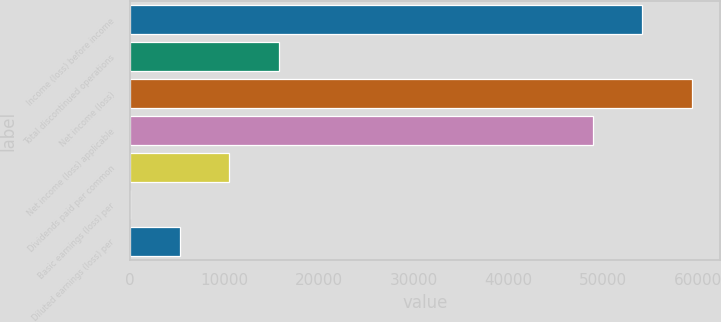<chart> <loc_0><loc_0><loc_500><loc_500><bar_chart><fcel>Income (loss) before income<fcel>Total discontinued operations<fcel>Net income (loss)<fcel>Net income (loss) applicable<fcel>Dividends paid per common<fcel>Basic earnings (loss) per<fcel>Diluted earnings (loss) per<nl><fcel>54153.9<fcel>15812.8<fcel>59424.8<fcel>48883<fcel>10541.9<fcel>0.17<fcel>5271.05<nl></chart> 